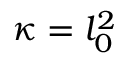<formula> <loc_0><loc_0><loc_500><loc_500>\kappa = l _ { 0 } ^ { 2 }</formula> 